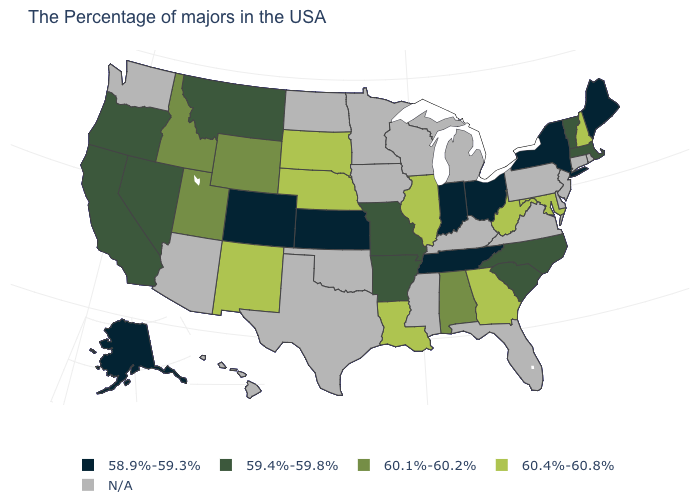Name the states that have a value in the range 58.9%-59.3%?
Answer briefly. Maine, New York, Ohio, Indiana, Tennessee, Kansas, Colorado, Alaska. Is the legend a continuous bar?
Short answer required. No. What is the value of Rhode Island?
Answer briefly. N/A. Among the states that border Nevada , does Oregon have the lowest value?
Keep it brief. Yes. What is the lowest value in states that border Vermont?
Be succinct. 58.9%-59.3%. What is the value of Florida?
Be succinct. N/A. Among the states that border Rhode Island , which have the lowest value?
Give a very brief answer. Massachusetts. Does the first symbol in the legend represent the smallest category?
Be succinct. Yes. What is the value of New Jersey?
Be succinct. N/A. How many symbols are there in the legend?
Write a very short answer. 5. Among the states that border North Carolina , which have the highest value?
Give a very brief answer. Georgia. What is the value of Ohio?
Write a very short answer. 58.9%-59.3%. Name the states that have a value in the range 60.1%-60.2%?
Write a very short answer. Alabama, Wyoming, Utah, Idaho. What is the highest value in states that border Arizona?
Be succinct. 60.4%-60.8%. Does Missouri have the highest value in the MidWest?
Keep it brief. No. 